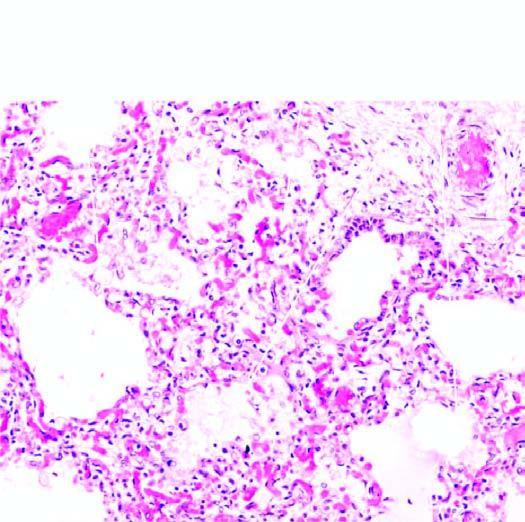do the air spaces contain pale oedema fluid and a few red cells?
Answer the question using a single word or phrase. Yes 